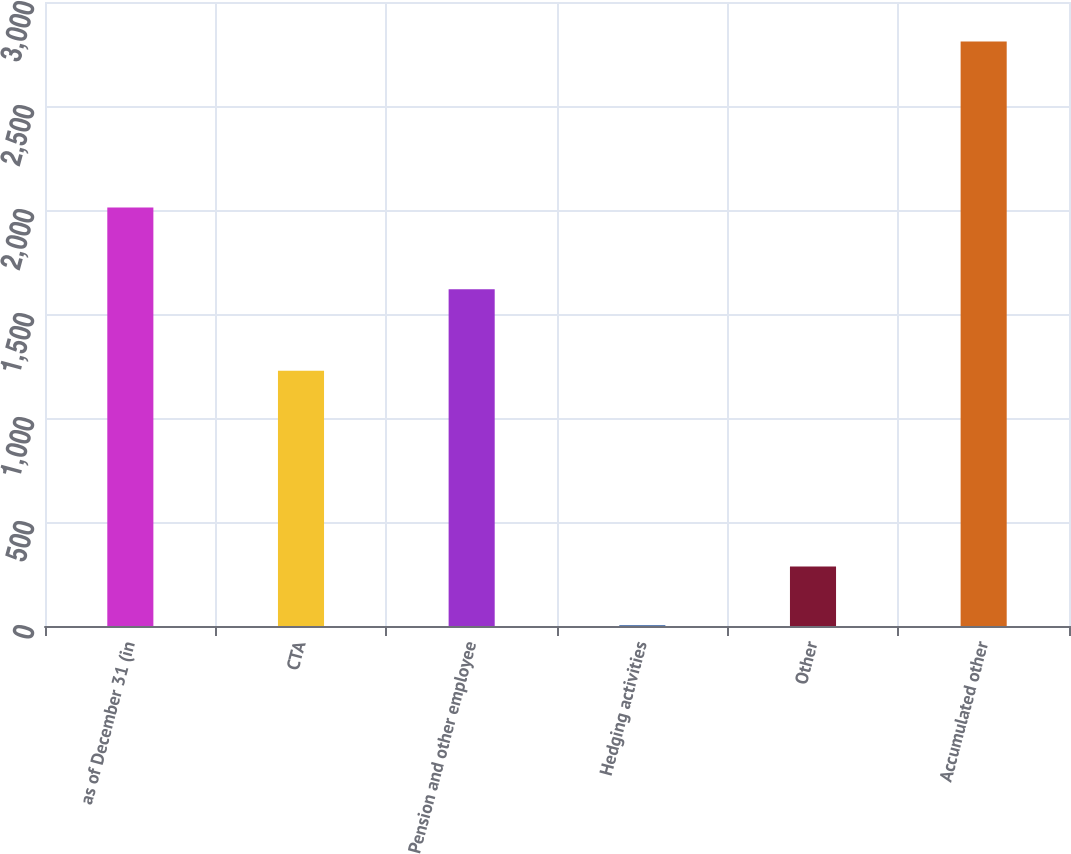Convert chart. <chart><loc_0><loc_0><loc_500><loc_500><bar_chart><fcel>as of December 31 (in<fcel>CTA<fcel>Pension and other employee<fcel>Hedging activities<fcel>Other<fcel>Accumulated other<nl><fcel>2012<fcel>1227<fcel>1619<fcel>5<fcel>285.5<fcel>2810<nl></chart> 